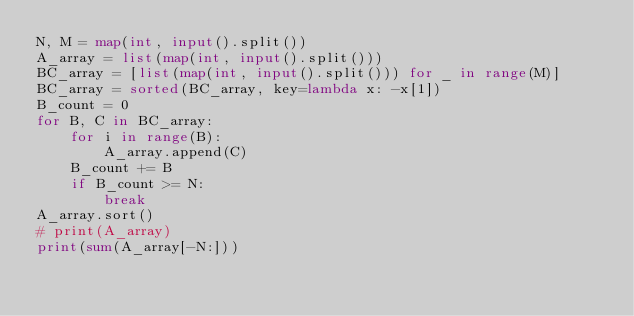Convert code to text. <code><loc_0><loc_0><loc_500><loc_500><_Python_>N, M = map(int, input().split())
A_array = list(map(int, input().split()))
BC_array = [list(map(int, input().split())) for _ in range(M)]
BC_array = sorted(BC_array, key=lambda x: -x[1])
B_count = 0
for B, C in BC_array:
    for i in range(B):
        A_array.append(C)
    B_count += B
    if B_count >= N:
        break
A_array.sort()
# print(A_array)
print(sum(A_array[-N:]))</code> 